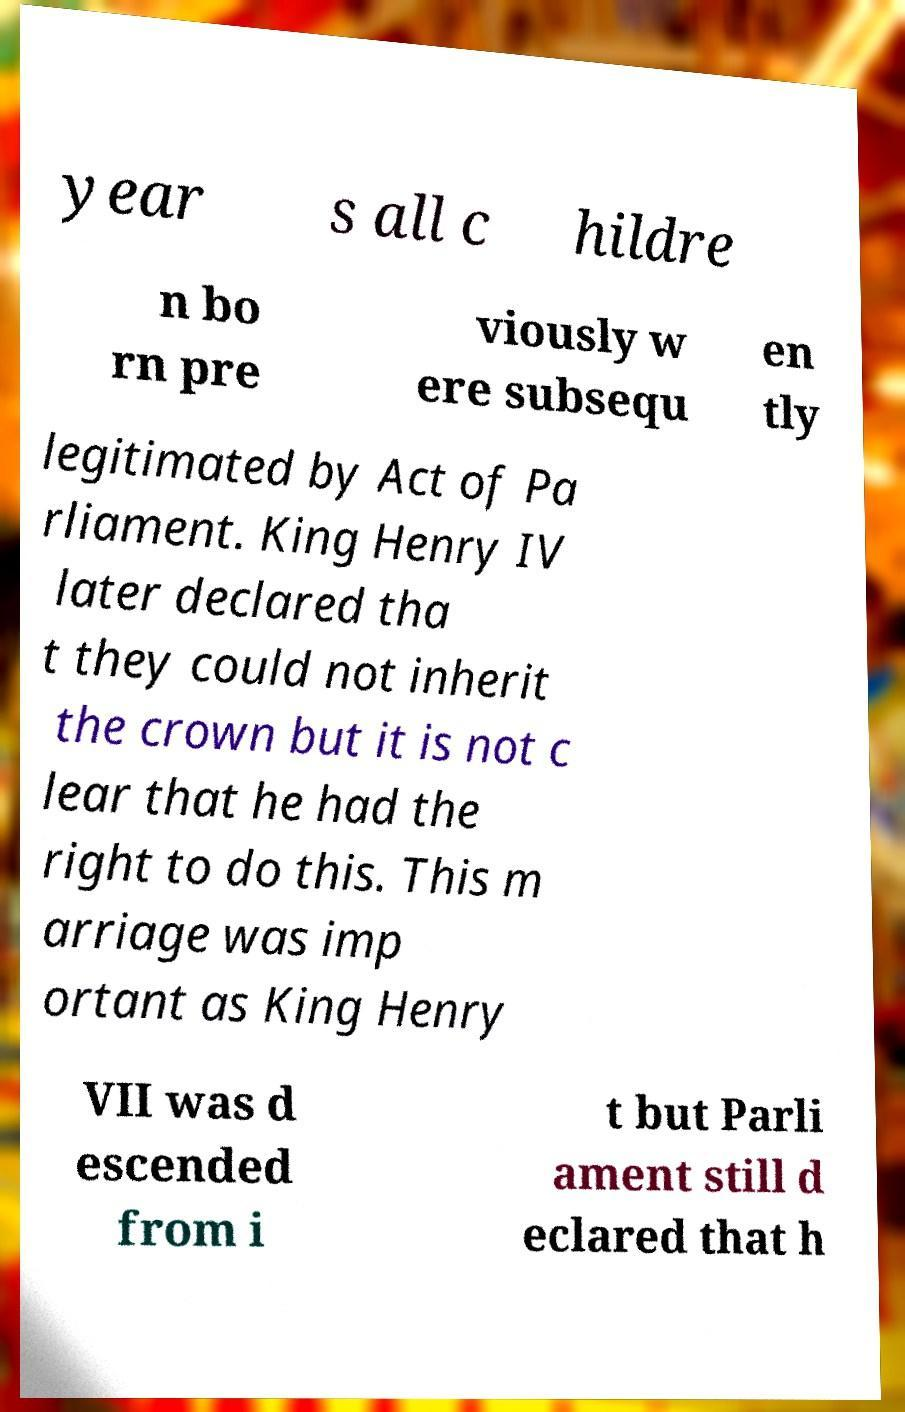I need the written content from this picture converted into text. Can you do that? year s all c hildre n bo rn pre viously w ere subsequ en tly legitimated by Act of Pa rliament. King Henry IV later declared tha t they could not inherit the crown but it is not c lear that he had the right to do this. This m arriage was imp ortant as King Henry VII was d escended from i t but Parli ament still d eclared that h 